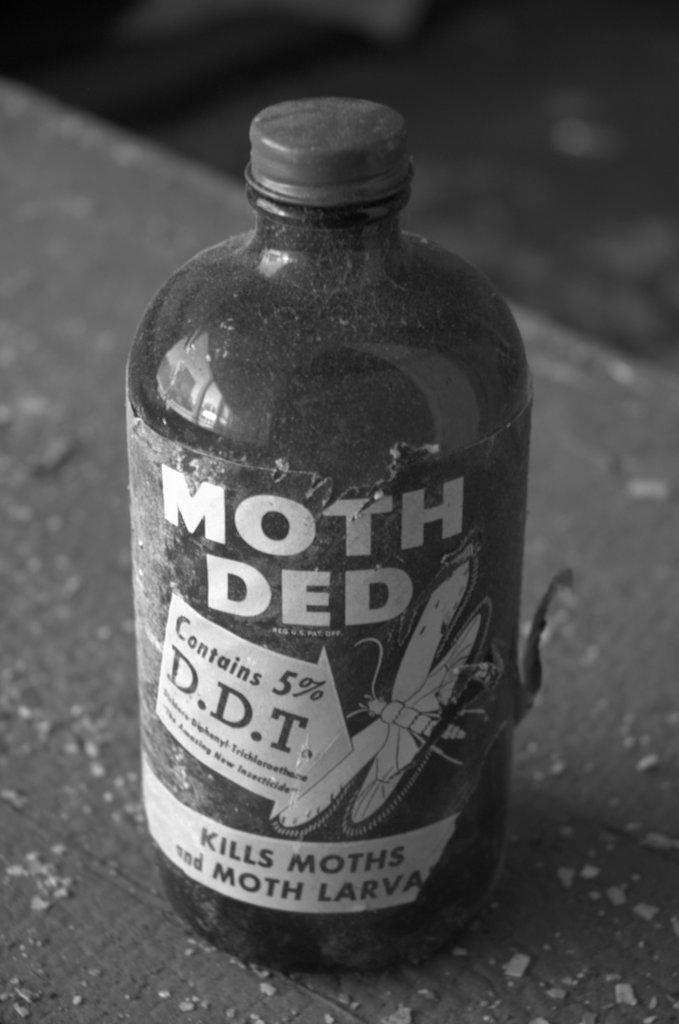What is the name on the bottle?
Make the answer very short. Moth ded. How much d.d.t does the bottle contain by volume?
Keep it short and to the point. 5%. 